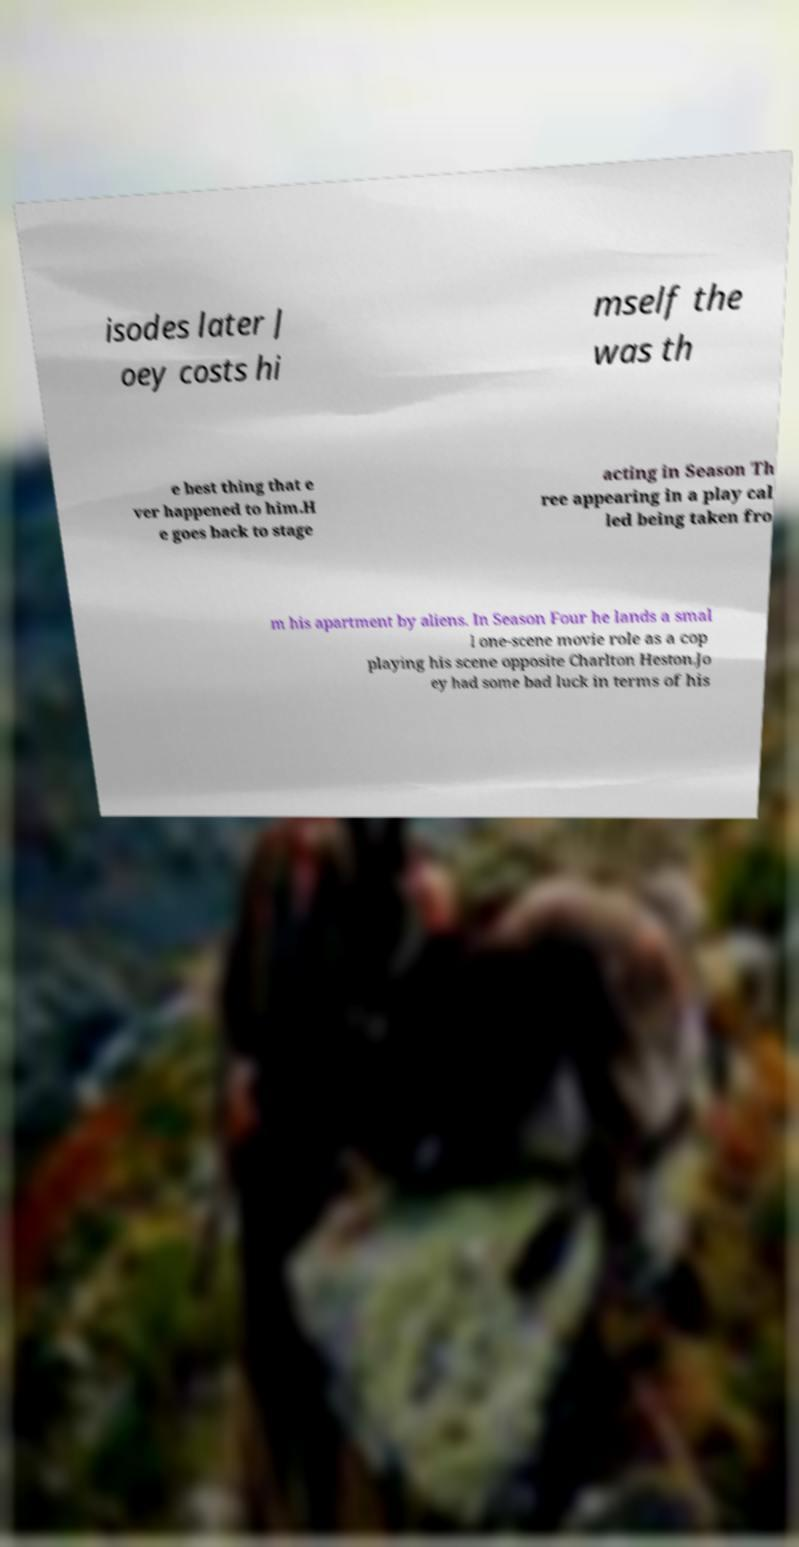Can you read and provide the text displayed in the image?This photo seems to have some interesting text. Can you extract and type it out for me? isodes later J oey costs hi mself the was th e best thing that e ver happened to him.H e goes back to stage acting in Season Th ree appearing in a play cal led being taken fro m his apartment by aliens. In Season Four he lands a smal l one-scene movie role as a cop playing his scene opposite Charlton Heston.Jo ey had some bad luck in terms of his 